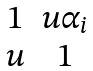Convert formula to latex. <formula><loc_0><loc_0><loc_500><loc_500>\begin{matrix} 1 & u \alpha _ { i } \\ u & 1 \end{matrix}</formula> 